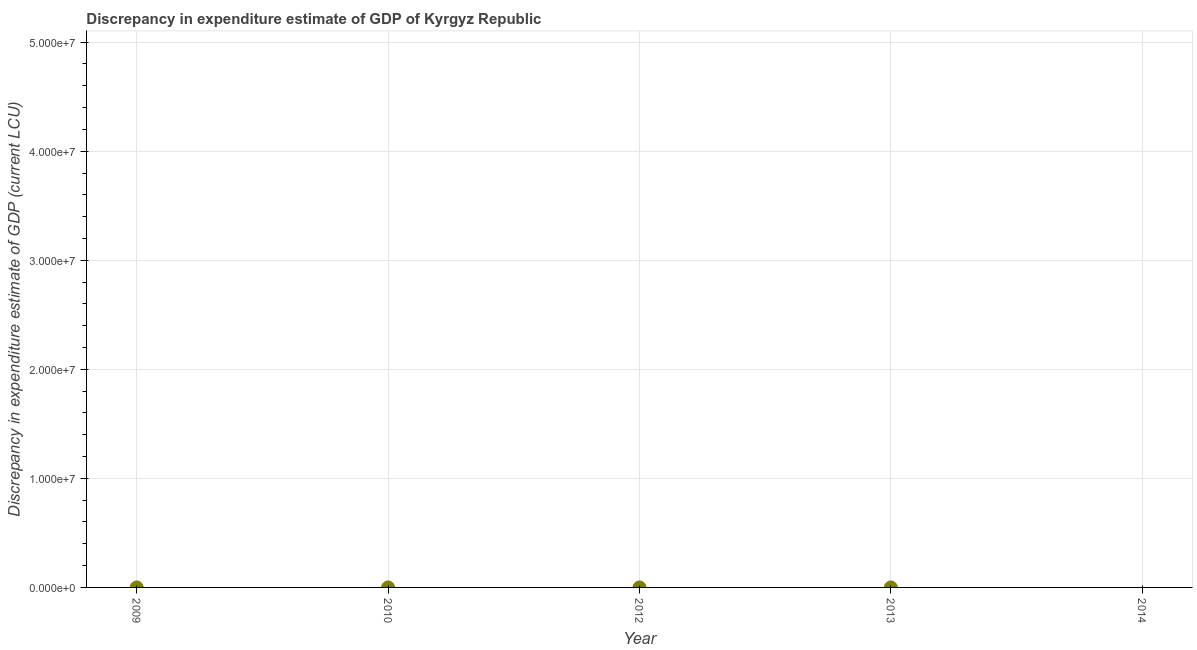What is the discrepancy in expenditure estimate of gdp in 2014?
Offer a very short reply. 0. Across all years, what is the maximum discrepancy in expenditure estimate of gdp?
Provide a short and direct response. 2.800000000000001e-5. Across all years, what is the minimum discrepancy in expenditure estimate of gdp?
Offer a very short reply. 0. What is the sum of the discrepancy in expenditure estimate of gdp?
Give a very brief answer. 3.600000000000001e-5. What is the difference between the discrepancy in expenditure estimate of gdp in 2010 and 2013?
Make the answer very short. 2.0000000000000012e-5. What is the average discrepancy in expenditure estimate of gdp per year?
Make the answer very short. 7.200000000000001e-6. In how many years, is the discrepancy in expenditure estimate of gdp greater than 48000000 LCU?
Provide a succinct answer. 0. Is the difference between the discrepancy in expenditure estimate of gdp in 2010 and 2013 greater than the difference between any two years?
Keep it short and to the point. No. What is the difference between the highest and the lowest discrepancy in expenditure estimate of gdp?
Keep it short and to the point. 2.800000000000001e-5. Does the discrepancy in expenditure estimate of gdp monotonically increase over the years?
Give a very brief answer. No. How many years are there in the graph?
Give a very brief answer. 5. Does the graph contain grids?
Ensure brevity in your answer.  Yes. What is the title of the graph?
Make the answer very short. Discrepancy in expenditure estimate of GDP of Kyrgyz Republic. What is the label or title of the Y-axis?
Give a very brief answer. Discrepancy in expenditure estimate of GDP (current LCU). What is the Discrepancy in expenditure estimate of GDP (current LCU) in 2010?
Keep it short and to the point. 2.800000000000001e-5. What is the Discrepancy in expenditure estimate of GDP (current LCU) in 2013?
Your answer should be very brief. 8e-6. What is the Discrepancy in expenditure estimate of GDP (current LCU) in 2014?
Make the answer very short. 0. What is the difference between the Discrepancy in expenditure estimate of GDP (current LCU) in 2010 and 2013?
Offer a very short reply. 2e-5. 